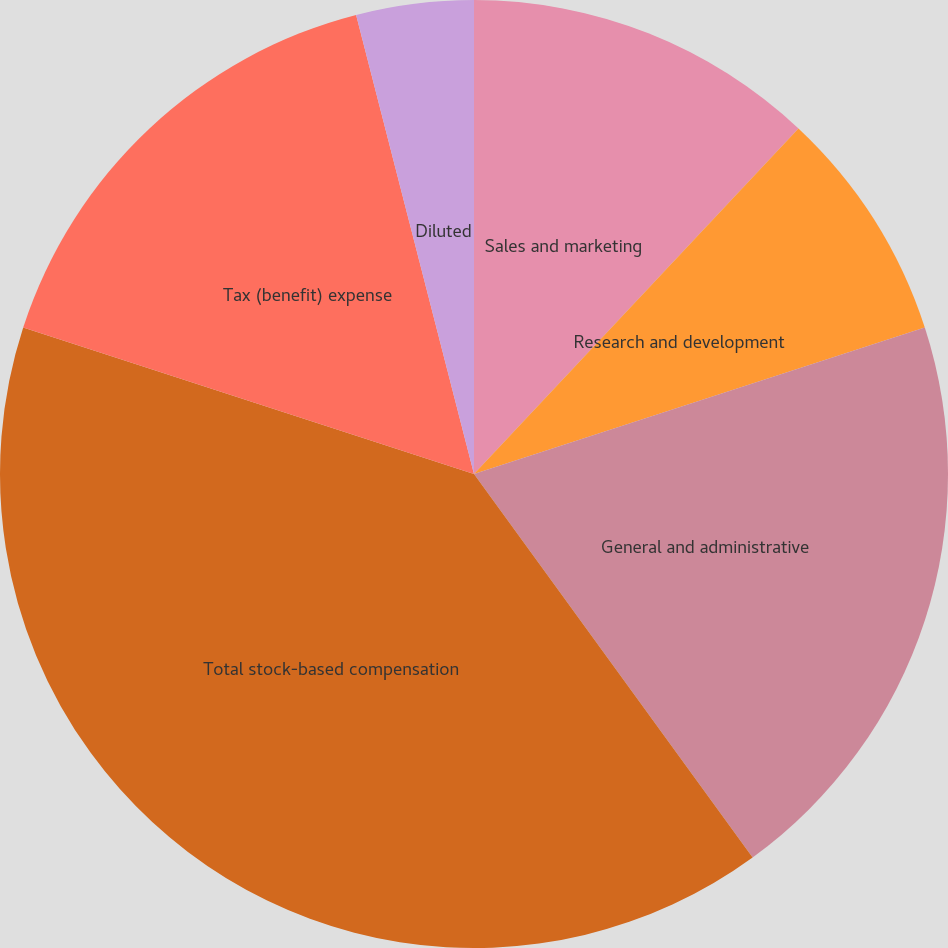Convert chart to OTSL. <chart><loc_0><loc_0><loc_500><loc_500><pie_chart><fcel>Sales and marketing<fcel>Research and development<fcel>General and administrative<fcel>Total stock-based compensation<fcel>Tax (benefit) expense<fcel>Basic<fcel>Diluted<nl><fcel>12.0%<fcel>8.0%<fcel>20.0%<fcel>40.0%<fcel>16.0%<fcel>0.0%<fcel>4.0%<nl></chart> 